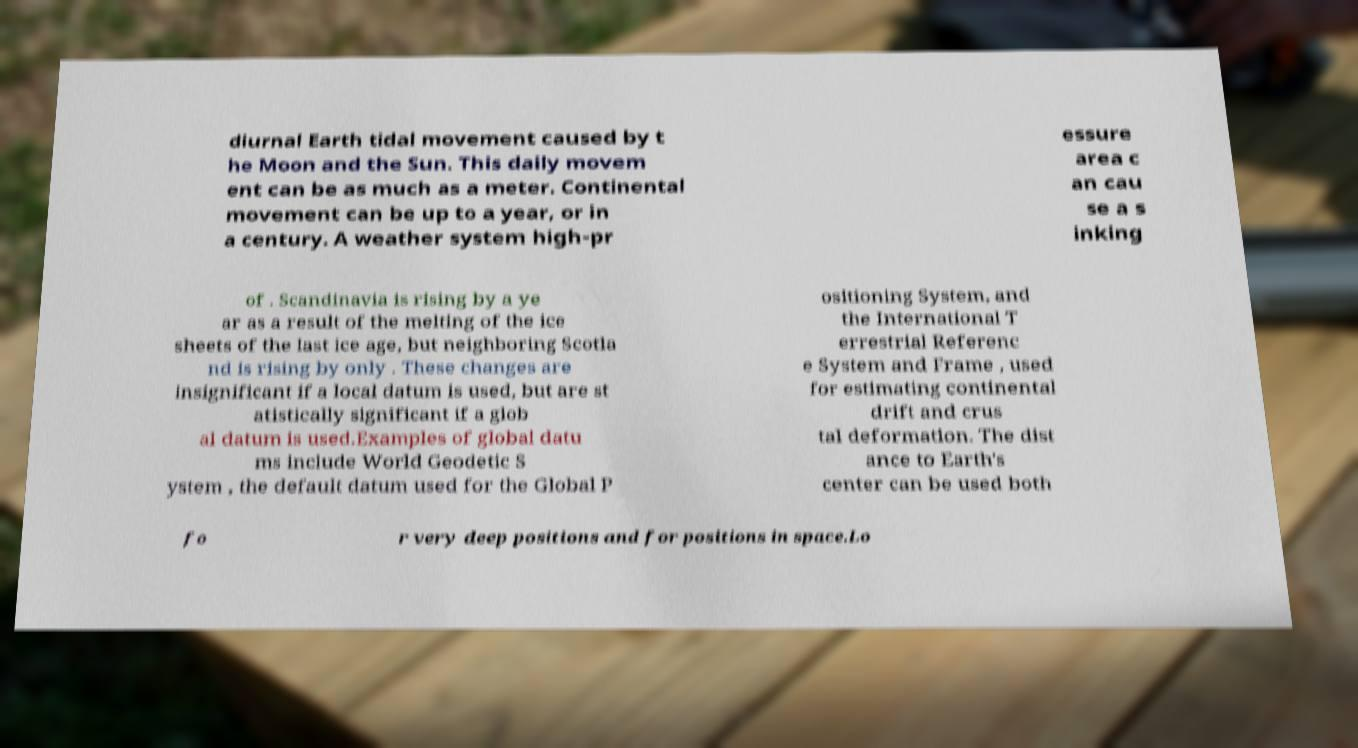Please read and relay the text visible in this image. What does it say? diurnal Earth tidal movement caused by t he Moon and the Sun. This daily movem ent can be as much as a meter. Continental movement can be up to a year, or in a century. A weather system high-pr essure area c an cau se a s inking of . Scandinavia is rising by a ye ar as a result of the melting of the ice sheets of the last ice age, but neighboring Scotla nd is rising by only . These changes are insignificant if a local datum is used, but are st atistically significant if a glob al datum is used.Examples of global datu ms include World Geodetic S ystem , the default datum used for the Global P ositioning System, and the International T errestrial Referenc e System and Frame , used for estimating continental drift and crus tal deformation. The dist ance to Earth's center can be used both fo r very deep positions and for positions in space.Lo 